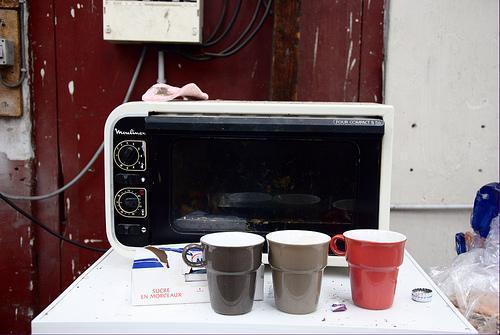How many mugs are on the counter?
Give a very brief answer. 3. 